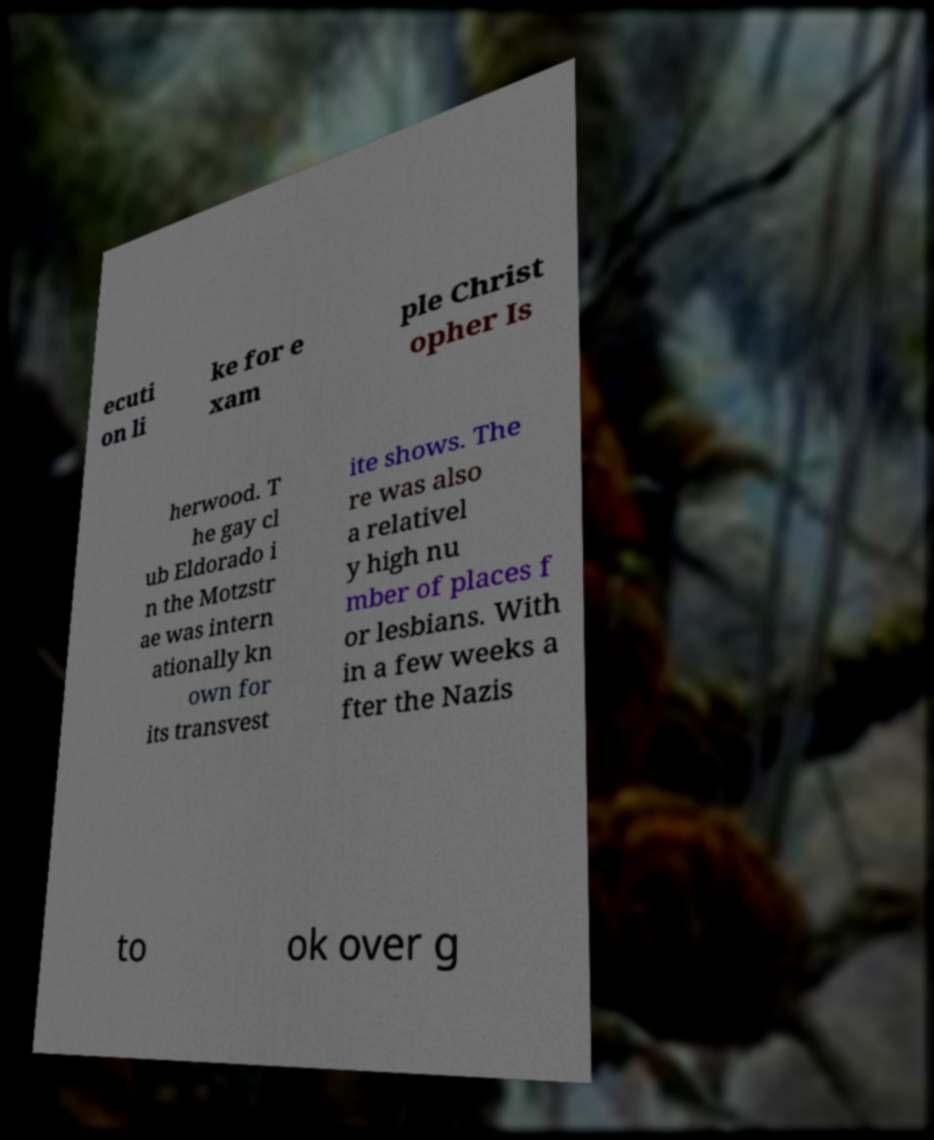Could you assist in decoding the text presented in this image and type it out clearly? ecuti on li ke for e xam ple Christ opher Is herwood. T he gay cl ub Eldorado i n the Motzstr ae was intern ationally kn own for its transvest ite shows. The re was also a relativel y high nu mber of places f or lesbians. With in a few weeks a fter the Nazis to ok over g 